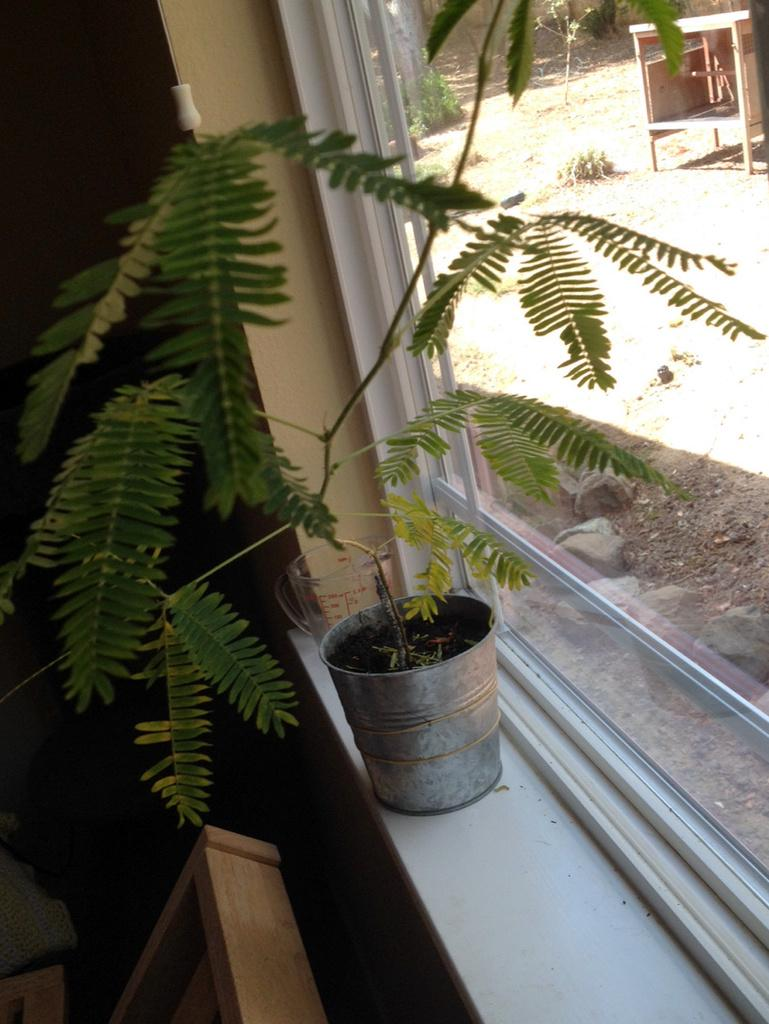What is the main subject of the image? The main subject of the image is a window of a house. Are there any objects visible inside the house through the window? Yes, there is a plant in a pot visible inside the house through the window. Are there any other objects visible in the image? Yes, there is a wooden box on the side in the image. Can you see a fireman or a queen in the image? No, there is no fireman or queen present in the image. Is there a bun visible in the image? There is no bun visible in the image. 